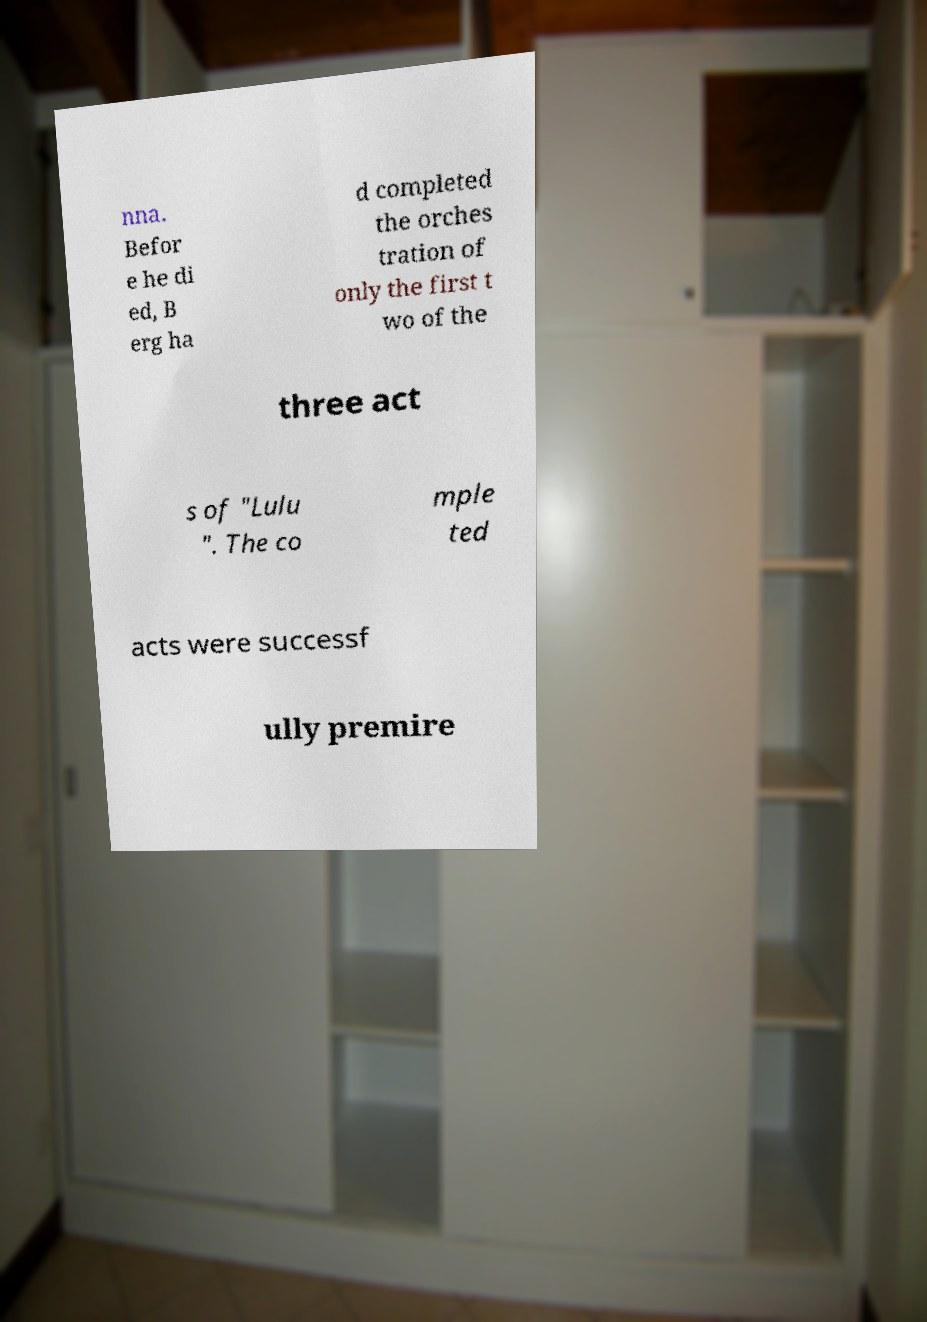Please read and relay the text visible in this image. What does it say? nna. Befor e he di ed, B erg ha d completed the orches tration of only the first t wo of the three act s of "Lulu ". The co mple ted acts were successf ully premire 